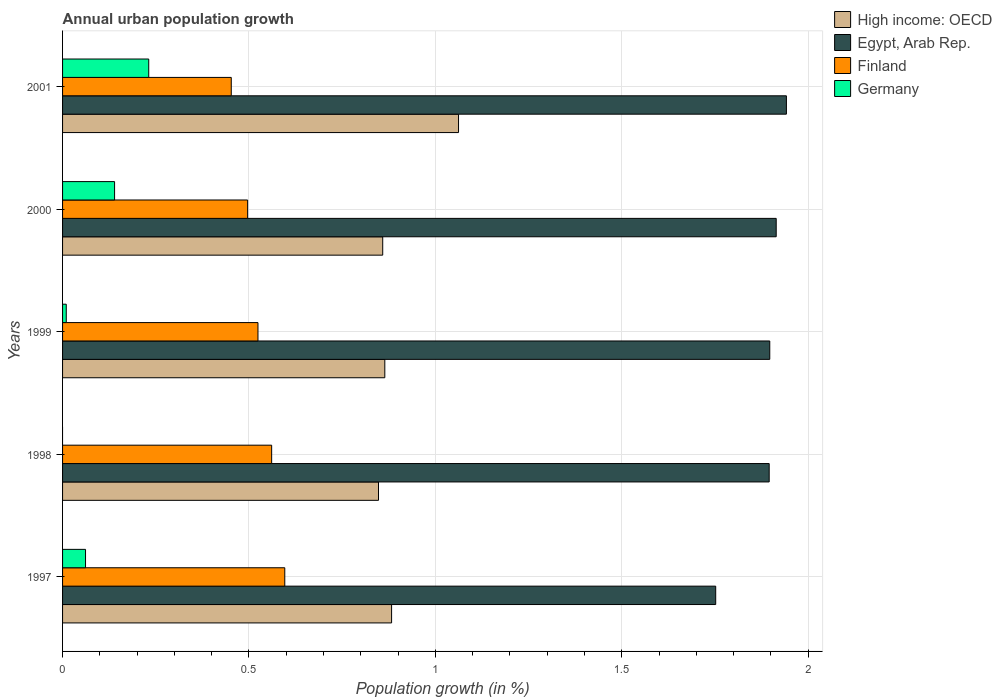How many different coloured bars are there?
Give a very brief answer. 4. How many groups of bars are there?
Make the answer very short. 5. Are the number of bars per tick equal to the number of legend labels?
Your response must be concise. No. Are the number of bars on each tick of the Y-axis equal?
Give a very brief answer. No. How many bars are there on the 3rd tick from the top?
Make the answer very short. 4. What is the label of the 5th group of bars from the top?
Make the answer very short. 1997. In how many cases, is the number of bars for a given year not equal to the number of legend labels?
Give a very brief answer. 1. What is the percentage of urban population growth in Germany in 1997?
Your response must be concise. 0.06. Across all years, what is the maximum percentage of urban population growth in Germany?
Ensure brevity in your answer.  0.23. Across all years, what is the minimum percentage of urban population growth in High income: OECD?
Your answer should be very brief. 0.85. What is the total percentage of urban population growth in Egypt, Arab Rep. in the graph?
Provide a short and direct response. 9.4. What is the difference between the percentage of urban population growth in Egypt, Arab Rep. in 1999 and that in 2001?
Your response must be concise. -0.04. What is the difference between the percentage of urban population growth in Finland in 1998 and the percentage of urban population growth in High income: OECD in 1999?
Ensure brevity in your answer.  -0.3. What is the average percentage of urban population growth in Finland per year?
Provide a succinct answer. 0.53. In the year 1997, what is the difference between the percentage of urban population growth in Egypt, Arab Rep. and percentage of urban population growth in Finland?
Your answer should be compact. 1.16. In how many years, is the percentage of urban population growth in Egypt, Arab Rep. greater than 0.9 %?
Your answer should be very brief. 5. What is the ratio of the percentage of urban population growth in Egypt, Arab Rep. in 1998 to that in 2000?
Your answer should be compact. 0.99. What is the difference between the highest and the second highest percentage of urban population growth in High income: OECD?
Your answer should be very brief. 0.18. What is the difference between the highest and the lowest percentage of urban population growth in High income: OECD?
Your response must be concise. 0.21. In how many years, is the percentage of urban population growth in High income: OECD greater than the average percentage of urban population growth in High income: OECD taken over all years?
Provide a succinct answer. 1. Is it the case that in every year, the sum of the percentage of urban population growth in Finland and percentage of urban population growth in Egypt, Arab Rep. is greater than the sum of percentage of urban population growth in Germany and percentage of urban population growth in High income: OECD?
Provide a short and direct response. Yes. Is it the case that in every year, the sum of the percentage of urban population growth in Egypt, Arab Rep. and percentage of urban population growth in Finland is greater than the percentage of urban population growth in Germany?
Your response must be concise. Yes. Does the graph contain any zero values?
Make the answer very short. Yes. Does the graph contain grids?
Your answer should be compact. Yes. How many legend labels are there?
Provide a short and direct response. 4. How are the legend labels stacked?
Your response must be concise. Vertical. What is the title of the graph?
Your response must be concise. Annual urban population growth. What is the label or title of the X-axis?
Provide a short and direct response. Population growth (in %). What is the Population growth (in %) in High income: OECD in 1997?
Give a very brief answer. 0.88. What is the Population growth (in %) of Egypt, Arab Rep. in 1997?
Your answer should be very brief. 1.75. What is the Population growth (in %) in Finland in 1997?
Ensure brevity in your answer.  0.6. What is the Population growth (in %) of Germany in 1997?
Give a very brief answer. 0.06. What is the Population growth (in %) of High income: OECD in 1998?
Provide a short and direct response. 0.85. What is the Population growth (in %) in Egypt, Arab Rep. in 1998?
Your answer should be very brief. 1.9. What is the Population growth (in %) of Finland in 1998?
Your answer should be very brief. 0.56. What is the Population growth (in %) in High income: OECD in 1999?
Provide a short and direct response. 0.86. What is the Population growth (in %) of Egypt, Arab Rep. in 1999?
Offer a terse response. 1.9. What is the Population growth (in %) of Finland in 1999?
Keep it short and to the point. 0.52. What is the Population growth (in %) in Germany in 1999?
Offer a very short reply. 0.01. What is the Population growth (in %) of High income: OECD in 2000?
Keep it short and to the point. 0.86. What is the Population growth (in %) of Egypt, Arab Rep. in 2000?
Your response must be concise. 1.91. What is the Population growth (in %) of Finland in 2000?
Your answer should be very brief. 0.5. What is the Population growth (in %) in Germany in 2000?
Your response must be concise. 0.14. What is the Population growth (in %) of High income: OECD in 2001?
Make the answer very short. 1.06. What is the Population growth (in %) in Egypt, Arab Rep. in 2001?
Make the answer very short. 1.94. What is the Population growth (in %) in Finland in 2001?
Keep it short and to the point. 0.45. What is the Population growth (in %) of Germany in 2001?
Provide a succinct answer. 0.23. Across all years, what is the maximum Population growth (in %) of High income: OECD?
Offer a terse response. 1.06. Across all years, what is the maximum Population growth (in %) of Egypt, Arab Rep.?
Your answer should be compact. 1.94. Across all years, what is the maximum Population growth (in %) in Finland?
Keep it short and to the point. 0.6. Across all years, what is the maximum Population growth (in %) of Germany?
Provide a succinct answer. 0.23. Across all years, what is the minimum Population growth (in %) in High income: OECD?
Your response must be concise. 0.85. Across all years, what is the minimum Population growth (in %) of Egypt, Arab Rep.?
Your answer should be compact. 1.75. Across all years, what is the minimum Population growth (in %) in Finland?
Give a very brief answer. 0.45. What is the total Population growth (in %) in High income: OECD in the graph?
Keep it short and to the point. 4.52. What is the total Population growth (in %) of Egypt, Arab Rep. in the graph?
Your response must be concise. 9.4. What is the total Population growth (in %) in Finland in the graph?
Give a very brief answer. 2.63. What is the total Population growth (in %) in Germany in the graph?
Offer a terse response. 0.44. What is the difference between the Population growth (in %) in High income: OECD in 1997 and that in 1998?
Give a very brief answer. 0.04. What is the difference between the Population growth (in %) in Egypt, Arab Rep. in 1997 and that in 1998?
Give a very brief answer. -0.14. What is the difference between the Population growth (in %) in Finland in 1997 and that in 1998?
Provide a short and direct response. 0.04. What is the difference between the Population growth (in %) of High income: OECD in 1997 and that in 1999?
Your answer should be very brief. 0.02. What is the difference between the Population growth (in %) in Egypt, Arab Rep. in 1997 and that in 1999?
Keep it short and to the point. -0.14. What is the difference between the Population growth (in %) of Finland in 1997 and that in 1999?
Your answer should be compact. 0.07. What is the difference between the Population growth (in %) of Germany in 1997 and that in 1999?
Ensure brevity in your answer.  0.05. What is the difference between the Population growth (in %) in High income: OECD in 1997 and that in 2000?
Your answer should be very brief. 0.02. What is the difference between the Population growth (in %) in Egypt, Arab Rep. in 1997 and that in 2000?
Keep it short and to the point. -0.16. What is the difference between the Population growth (in %) of Finland in 1997 and that in 2000?
Provide a short and direct response. 0.1. What is the difference between the Population growth (in %) in Germany in 1997 and that in 2000?
Provide a succinct answer. -0.08. What is the difference between the Population growth (in %) in High income: OECD in 1997 and that in 2001?
Ensure brevity in your answer.  -0.18. What is the difference between the Population growth (in %) in Egypt, Arab Rep. in 1997 and that in 2001?
Keep it short and to the point. -0.19. What is the difference between the Population growth (in %) in Finland in 1997 and that in 2001?
Provide a succinct answer. 0.14. What is the difference between the Population growth (in %) in Germany in 1997 and that in 2001?
Provide a succinct answer. -0.17. What is the difference between the Population growth (in %) in High income: OECD in 1998 and that in 1999?
Provide a short and direct response. -0.02. What is the difference between the Population growth (in %) of Egypt, Arab Rep. in 1998 and that in 1999?
Ensure brevity in your answer.  -0. What is the difference between the Population growth (in %) of Finland in 1998 and that in 1999?
Your response must be concise. 0.04. What is the difference between the Population growth (in %) of High income: OECD in 1998 and that in 2000?
Provide a succinct answer. -0.01. What is the difference between the Population growth (in %) in Egypt, Arab Rep. in 1998 and that in 2000?
Offer a very short reply. -0.02. What is the difference between the Population growth (in %) in Finland in 1998 and that in 2000?
Make the answer very short. 0.06. What is the difference between the Population growth (in %) in High income: OECD in 1998 and that in 2001?
Provide a succinct answer. -0.21. What is the difference between the Population growth (in %) of Egypt, Arab Rep. in 1998 and that in 2001?
Keep it short and to the point. -0.05. What is the difference between the Population growth (in %) in Finland in 1998 and that in 2001?
Your answer should be compact. 0.11. What is the difference between the Population growth (in %) of High income: OECD in 1999 and that in 2000?
Your answer should be very brief. 0.01. What is the difference between the Population growth (in %) of Egypt, Arab Rep. in 1999 and that in 2000?
Ensure brevity in your answer.  -0.02. What is the difference between the Population growth (in %) of Finland in 1999 and that in 2000?
Your answer should be compact. 0.03. What is the difference between the Population growth (in %) of Germany in 1999 and that in 2000?
Your response must be concise. -0.13. What is the difference between the Population growth (in %) in High income: OECD in 1999 and that in 2001?
Your response must be concise. -0.2. What is the difference between the Population growth (in %) in Egypt, Arab Rep. in 1999 and that in 2001?
Offer a terse response. -0.04. What is the difference between the Population growth (in %) of Finland in 1999 and that in 2001?
Provide a succinct answer. 0.07. What is the difference between the Population growth (in %) in Germany in 1999 and that in 2001?
Offer a terse response. -0.22. What is the difference between the Population growth (in %) in High income: OECD in 2000 and that in 2001?
Your answer should be compact. -0.2. What is the difference between the Population growth (in %) of Egypt, Arab Rep. in 2000 and that in 2001?
Provide a short and direct response. -0.03. What is the difference between the Population growth (in %) of Finland in 2000 and that in 2001?
Make the answer very short. 0.04. What is the difference between the Population growth (in %) in Germany in 2000 and that in 2001?
Your answer should be very brief. -0.09. What is the difference between the Population growth (in %) in High income: OECD in 1997 and the Population growth (in %) in Egypt, Arab Rep. in 1998?
Provide a succinct answer. -1.01. What is the difference between the Population growth (in %) in High income: OECD in 1997 and the Population growth (in %) in Finland in 1998?
Your answer should be very brief. 0.32. What is the difference between the Population growth (in %) of Egypt, Arab Rep. in 1997 and the Population growth (in %) of Finland in 1998?
Your response must be concise. 1.19. What is the difference between the Population growth (in %) of High income: OECD in 1997 and the Population growth (in %) of Egypt, Arab Rep. in 1999?
Make the answer very short. -1.01. What is the difference between the Population growth (in %) of High income: OECD in 1997 and the Population growth (in %) of Finland in 1999?
Your answer should be very brief. 0.36. What is the difference between the Population growth (in %) of High income: OECD in 1997 and the Population growth (in %) of Germany in 1999?
Your answer should be very brief. 0.87. What is the difference between the Population growth (in %) in Egypt, Arab Rep. in 1997 and the Population growth (in %) in Finland in 1999?
Your response must be concise. 1.23. What is the difference between the Population growth (in %) of Egypt, Arab Rep. in 1997 and the Population growth (in %) of Germany in 1999?
Your answer should be compact. 1.74. What is the difference between the Population growth (in %) of Finland in 1997 and the Population growth (in %) of Germany in 1999?
Your answer should be compact. 0.59. What is the difference between the Population growth (in %) of High income: OECD in 1997 and the Population growth (in %) of Egypt, Arab Rep. in 2000?
Make the answer very short. -1.03. What is the difference between the Population growth (in %) of High income: OECD in 1997 and the Population growth (in %) of Finland in 2000?
Ensure brevity in your answer.  0.39. What is the difference between the Population growth (in %) in High income: OECD in 1997 and the Population growth (in %) in Germany in 2000?
Ensure brevity in your answer.  0.74. What is the difference between the Population growth (in %) of Egypt, Arab Rep. in 1997 and the Population growth (in %) of Finland in 2000?
Your response must be concise. 1.26. What is the difference between the Population growth (in %) of Egypt, Arab Rep. in 1997 and the Population growth (in %) of Germany in 2000?
Offer a very short reply. 1.61. What is the difference between the Population growth (in %) in Finland in 1997 and the Population growth (in %) in Germany in 2000?
Your answer should be compact. 0.46. What is the difference between the Population growth (in %) in High income: OECD in 1997 and the Population growth (in %) in Egypt, Arab Rep. in 2001?
Make the answer very short. -1.06. What is the difference between the Population growth (in %) in High income: OECD in 1997 and the Population growth (in %) in Finland in 2001?
Your answer should be very brief. 0.43. What is the difference between the Population growth (in %) in High income: OECD in 1997 and the Population growth (in %) in Germany in 2001?
Make the answer very short. 0.65. What is the difference between the Population growth (in %) of Egypt, Arab Rep. in 1997 and the Population growth (in %) of Finland in 2001?
Your answer should be compact. 1.3. What is the difference between the Population growth (in %) in Egypt, Arab Rep. in 1997 and the Population growth (in %) in Germany in 2001?
Give a very brief answer. 1.52. What is the difference between the Population growth (in %) in Finland in 1997 and the Population growth (in %) in Germany in 2001?
Ensure brevity in your answer.  0.36. What is the difference between the Population growth (in %) in High income: OECD in 1998 and the Population growth (in %) in Egypt, Arab Rep. in 1999?
Ensure brevity in your answer.  -1.05. What is the difference between the Population growth (in %) in High income: OECD in 1998 and the Population growth (in %) in Finland in 1999?
Give a very brief answer. 0.32. What is the difference between the Population growth (in %) in High income: OECD in 1998 and the Population growth (in %) in Germany in 1999?
Ensure brevity in your answer.  0.84. What is the difference between the Population growth (in %) of Egypt, Arab Rep. in 1998 and the Population growth (in %) of Finland in 1999?
Offer a terse response. 1.37. What is the difference between the Population growth (in %) in Egypt, Arab Rep. in 1998 and the Population growth (in %) in Germany in 1999?
Give a very brief answer. 1.89. What is the difference between the Population growth (in %) of Finland in 1998 and the Population growth (in %) of Germany in 1999?
Your answer should be compact. 0.55. What is the difference between the Population growth (in %) in High income: OECD in 1998 and the Population growth (in %) in Egypt, Arab Rep. in 2000?
Your response must be concise. -1.07. What is the difference between the Population growth (in %) in High income: OECD in 1998 and the Population growth (in %) in Finland in 2000?
Keep it short and to the point. 0.35. What is the difference between the Population growth (in %) of High income: OECD in 1998 and the Population growth (in %) of Germany in 2000?
Offer a very short reply. 0.71. What is the difference between the Population growth (in %) of Egypt, Arab Rep. in 1998 and the Population growth (in %) of Finland in 2000?
Make the answer very short. 1.4. What is the difference between the Population growth (in %) in Egypt, Arab Rep. in 1998 and the Population growth (in %) in Germany in 2000?
Your answer should be very brief. 1.76. What is the difference between the Population growth (in %) of Finland in 1998 and the Population growth (in %) of Germany in 2000?
Your answer should be very brief. 0.42. What is the difference between the Population growth (in %) in High income: OECD in 1998 and the Population growth (in %) in Egypt, Arab Rep. in 2001?
Your answer should be very brief. -1.09. What is the difference between the Population growth (in %) in High income: OECD in 1998 and the Population growth (in %) in Finland in 2001?
Your response must be concise. 0.4. What is the difference between the Population growth (in %) of High income: OECD in 1998 and the Population growth (in %) of Germany in 2001?
Provide a succinct answer. 0.62. What is the difference between the Population growth (in %) of Egypt, Arab Rep. in 1998 and the Population growth (in %) of Finland in 2001?
Your answer should be compact. 1.44. What is the difference between the Population growth (in %) in Egypt, Arab Rep. in 1998 and the Population growth (in %) in Germany in 2001?
Your response must be concise. 1.66. What is the difference between the Population growth (in %) in Finland in 1998 and the Population growth (in %) in Germany in 2001?
Your answer should be very brief. 0.33. What is the difference between the Population growth (in %) of High income: OECD in 1999 and the Population growth (in %) of Egypt, Arab Rep. in 2000?
Your answer should be compact. -1.05. What is the difference between the Population growth (in %) of High income: OECD in 1999 and the Population growth (in %) of Finland in 2000?
Your answer should be very brief. 0.37. What is the difference between the Population growth (in %) of High income: OECD in 1999 and the Population growth (in %) of Germany in 2000?
Offer a terse response. 0.72. What is the difference between the Population growth (in %) of Egypt, Arab Rep. in 1999 and the Population growth (in %) of Finland in 2000?
Make the answer very short. 1.4. What is the difference between the Population growth (in %) in Egypt, Arab Rep. in 1999 and the Population growth (in %) in Germany in 2000?
Your response must be concise. 1.76. What is the difference between the Population growth (in %) of Finland in 1999 and the Population growth (in %) of Germany in 2000?
Provide a short and direct response. 0.38. What is the difference between the Population growth (in %) of High income: OECD in 1999 and the Population growth (in %) of Egypt, Arab Rep. in 2001?
Your response must be concise. -1.08. What is the difference between the Population growth (in %) of High income: OECD in 1999 and the Population growth (in %) of Finland in 2001?
Your answer should be compact. 0.41. What is the difference between the Population growth (in %) of High income: OECD in 1999 and the Population growth (in %) of Germany in 2001?
Provide a succinct answer. 0.63. What is the difference between the Population growth (in %) in Egypt, Arab Rep. in 1999 and the Population growth (in %) in Finland in 2001?
Keep it short and to the point. 1.44. What is the difference between the Population growth (in %) of Egypt, Arab Rep. in 1999 and the Population growth (in %) of Germany in 2001?
Your response must be concise. 1.67. What is the difference between the Population growth (in %) of Finland in 1999 and the Population growth (in %) of Germany in 2001?
Your answer should be compact. 0.29. What is the difference between the Population growth (in %) in High income: OECD in 2000 and the Population growth (in %) in Egypt, Arab Rep. in 2001?
Make the answer very short. -1.08. What is the difference between the Population growth (in %) in High income: OECD in 2000 and the Population growth (in %) in Finland in 2001?
Keep it short and to the point. 0.41. What is the difference between the Population growth (in %) of High income: OECD in 2000 and the Population growth (in %) of Germany in 2001?
Keep it short and to the point. 0.63. What is the difference between the Population growth (in %) of Egypt, Arab Rep. in 2000 and the Population growth (in %) of Finland in 2001?
Ensure brevity in your answer.  1.46. What is the difference between the Population growth (in %) of Egypt, Arab Rep. in 2000 and the Population growth (in %) of Germany in 2001?
Keep it short and to the point. 1.68. What is the difference between the Population growth (in %) of Finland in 2000 and the Population growth (in %) of Germany in 2001?
Offer a terse response. 0.27. What is the average Population growth (in %) of High income: OECD per year?
Keep it short and to the point. 0.9. What is the average Population growth (in %) in Egypt, Arab Rep. per year?
Offer a very short reply. 1.88. What is the average Population growth (in %) in Finland per year?
Ensure brevity in your answer.  0.53. What is the average Population growth (in %) in Germany per year?
Keep it short and to the point. 0.09. In the year 1997, what is the difference between the Population growth (in %) in High income: OECD and Population growth (in %) in Egypt, Arab Rep.?
Give a very brief answer. -0.87. In the year 1997, what is the difference between the Population growth (in %) in High income: OECD and Population growth (in %) in Finland?
Make the answer very short. 0.29. In the year 1997, what is the difference between the Population growth (in %) of High income: OECD and Population growth (in %) of Germany?
Keep it short and to the point. 0.82. In the year 1997, what is the difference between the Population growth (in %) of Egypt, Arab Rep. and Population growth (in %) of Finland?
Offer a terse response. 1.16. In the year 1997, what is the difference between the Population growth (in %) in Egypt, Arab Rep. and Population growth (in %) in Germany?
Keep it short and to the point. 1.69. In the year 1997, what is the difference between the Population growth (in %) in Finland and Population growth (in %) in Germany?
Keep it short and to the point. 0.53. In the year 1998, what is the difference between the Population growth (in %) of High income: OECD and Population growth (in %) of Egypt, Arab Rep.?
Your answer should be very brief. -1.05. In the year 1998, what is the difference between the Population growth (in %) of High income: OECD and Population growth (in %) of Finland?
Your answer should be very brief. 0.29. In the year 1998, what is the difference between the Population growth (in %) of Egypt, Arab Rep. and Population growth (in %) of Finland?
Offer a very short reply. 1.33. In the year 1999, what is the difference between the Population growth (in %) of High income: OECD and Population growth (in %) of Egypt, Arab Rep.?
Your response must be concise. -1.03. In the year 1999, what is the difference between the Population growth (in %) of High income: OECD and Population growth (in %) of Finland?
Your answer should be very brief. 0.34. In the year 1999, what is the difference between the Population growth (in %) in High income: OECD and Population growth (in %) in Germany?
Your answer should be very brief. 0.85. In the year 1999, what is the difference between the Population growth (in %) of Egypt, Arab Rep. and Population growth (in %) of Finland?
Ensure brevity in your answer.  1.37. In the year 1999, what is the difference between the Population growth (in %) in Egypt, Arab Rep. and Population growth (in %) in Germany?
Provide a short and direct response. 1.89. In the year 1999, what is the difference between the Population growth (in %) of Finland and Population growth (in %) of Germany?
Provide a short and direct response. 0.51. In the year 2000, what is the difference between the Population growth (in %) in High income: OECD and Population growth (in %) in Egypt, Arab Rep.?
Offer a terse response. -1.06. In the year 2000, what is the difference between the Population growth (in %) of High income: OECD and Population growth (in %) of Finland?
Your answer should be compact. 0.36. In the year 2000, what is the difference between the Population growth (in %) in High income: OECD and Population growth (in %) in Germany?
Offer a very short reply. 0.72. In the year 2000, what is the difference between the Population growth (in %) of Egypt, Arab Rep. and Population growth (in %) of Finland?
Provide a succinct answer. 1.42. In the year 2000, what is the difference between the Population growth (in %) in Egypt, Arab Rep. and Population growth (in %) in Germany?
Make the answer very short. 1.77. In the year 2000, what is the difference between the Population growth (in %) in Finland and Population growth (in %) in Germany?
Make the answer very short. 0.36. In the year 2001, what is the difference between the Population growth (in %) in High income: OECD and Population growth (in %) in Egypt, Arab Rep.?
Your answer should be compact. -0.88. In the year 2001, what is the difference between the Population growth (in %) in High income: OECD and Population growth (in %) in Finland?
Your answer should be very brief. 0.61. In the year 2001, what is the difference between the Population growth (in %) of High income: OECD and Population growth (in %) of Germany?
Provide a short and direct response. 0.83. In the year 2001, what is the difference between the Population growth (in %) in Egypt, Arab Rep. and Population growth (in %) in Finland?
Provide a succinct answer. 1.49. In the year 2001, what is the difference between the Population growth (in %) in Egypt, Arab Rep. and Population growth (in %) in Germany?
Make the answer very short. 1.71. In the year 2001, what is the difference between the Population growth (in %) of Finland and Population growth (in %) of Germany?
Make the answer very short. 0.22. What is the ratio of the Population growth (in %) of High income: OECD in 1997 to that in 1998?
Ensure brevity in your answer.  1.04. What is the ratio of the Population growth (in %) in Egypt, Arab Rep. in 1997 to that in 1998?
Offer a very short reply. 0.92. What is the ratio of the Population growth (in %) of Finland in 1997 to that in 1998?
Offer a very short reply. 1.06. What is the ratio of the Population growth (in %) of Egypt, Arab Rep. in 1997 to that in 1999?
Ensure brevity in your answer.  0.92. What is the ratio of the Population growth (in %) in Finland in 1997 to that in 1999?
Ensure brevity in your answer.  1.14. What is the ratio of the Population growth (in %) in Germany in 1997 to that in 1999?
Give a very brief answer. 6.22. What is the ratio of the Population growth (in %) in High income: OECD in 1997 to that in 2000?
Ensure brevity in your answer.  1.03. What is the ratio of the Population growth (in %) of Egypt, Arab Rep. in 1997 to that in 2000?
Ensure brevity in your answer.  0.92. What is the ratio of the Population growth (in %) in Finland in 1997 to that in 2000?
Make the answer very short. 1.2. What is the ratio of the Population growth (in %) of Germany in 1997 to that in 2000?
Give a very brief answer. 0.44. What is the ratio of the Population growth (in %) of High income: OECD in 1997 to that in 2001?
Your answer should be compact. 0.83. What is the ratio of the Population growth (in %) in Egypt, Arab Rep. in 1997 to that in 2001?
Ensure brevity in your answer.  0.9. What is the ratio of the Population growth (in %) of Finland in 1997 to that in 2001?
Offer a terse response. 1.32. What is the ratio of the Population growth (in %) in Germany in 1997 to that in 2001?
Make the answer very short. 0.27. What is the ratio of the Population growth (in %) of High income: OECD in 1998 to that in 1999?
Provide a short and direct response. 0.98. What is the ratio of the Population growth (in %) in Egypt, Arab Rep. in 1998 to that in 1999?
Offer a very short reply. 1. What is the ratio of the Population growth (in %) in Finland in 1998 to that in 1999?
Ensure brevity in your answer.  1.07. What is the ratio of the Population growth (in %) of Egypt, Arab Rep. in 1998 to that in 2000?
Offer a very short reply. 0.99. What is the ratio of the Population growth (in %) in Finland in 1998 to that in 2000?
Give a very brief answer. 1.13. What is the ratio of the Population growth (in %) in High income: OECD in 1998 to that in 2001?
Provide a short and direct response. 0.8. What is the ratio of the Population growth (in %) of Egypt, Arab Rep. in 1998 to that in 2001?
Provide a short and direct response. 0.98. What is the ratio of the Population growth (in %) in Finland in 1998 to that in 2001?
Give a very brief answer. 1.24. What is the ratio of the Population growth (in %) of High income: OECD in 1999 to that in 2000?
Your answer should be compact. 1.01. What is the ratio of the Population growth (in %) of Finland in 1999 to that in 2000?
Your answer should be compact. 1.06. What is the ratio of the Population growth (in %) of Germany in 1999 to that in 2000?
Make the answer very short. 0.07. What is the ratio of the Population growth (in %) of High income: OECD in 1999 to that in 2001?
Your response must be concise. 0.81. What is the ratio of the Population growth (in %) in Finland in 1999 to that in 2001?
Provide a short and direct response. 1.16. What is the ratio of the Population growth (in %) of Germany in 1999 to that in 2001?
Keep it short and to the point. 0.04. What is the ratio of the Population growth (in %) of High income: OECD in 2000 to that in 2001?
Offer a terse response. 0.81. What is the ratio of the Population growth (in %) of Egypt, Arab Rep. in 2000 to that in 2001?
Keep it short and to the point. 0.99. What is the ratio of the Population growth (in %) of Finland in 2000 to that in 2001?
Ensure brevity in your answer.  1.1. What is the ratio of the Population growth (in %) in Germany in 2000 to that in 2001?
Your answer should be compact. 0.6. What is the difference between the highest and the second highest Population growth (in %) of High income: OECD?
Provide a succinct answer. 0.18. What is the difference between the highest and the second highest Population growth (in %) in Egypt, Arab Rep.?
Provide a succinct answer. 0.03. What is the difference between the highest and the second highest Population growth (in %) of Finland?
Provide a succinct answer. 0.04. What is the difference between the highest and the second highest Population growth (in %) in Germany?
Make the answer very short. 0.09. What is the difference between the highest and the lowest Population growth (in %) of High income: OECD?
Offer a terse response. 0.21. What is the difference between the highest and the lowest Population growth (in %) of Egypt, Arab Rep.?
Provide a succinct answer. 0.19. What is the difference between the highest and the lowest Population growth (in %) in Finland?
Provide a short and direct response. 0.14. What is the difference between the highest and the lowest Population growth (in %) of Germany?
Provide a succinct answer. 0.23. 